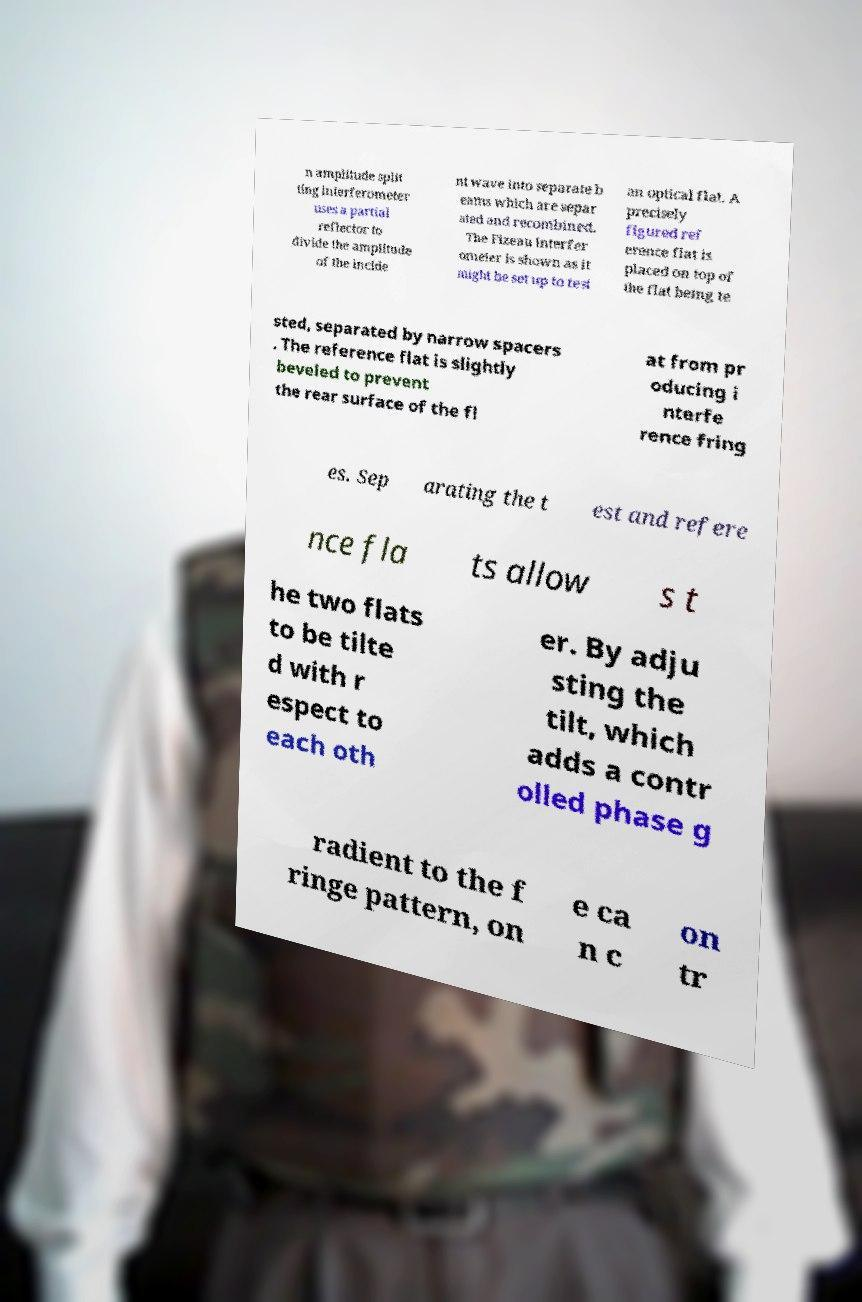Please read and relay the text visible in this image. What does it say? n amplitude split ting interferometer uses a partial reflector to divide the amplitude of the incide nt wave into separate b eams which are separ ated and recombined. The Fizeau interfer ometer is shown as it might be set up to test an optical flat. A precisely figured ref erence flat is placed on top of the flat being te sted, separated by narrow spacers . The reference flat is slightly beveled to prevent the rear surface of the fl at from pr oducing i nterfe rence fring es. Sep arating the t est and refere nce fla ts allow s t he two flats to be tilte d with r espect to each oth er. By adju sting the tilt, which adds a contr olled phase g radient to the f ringe pattern, on e ca n c on tr 